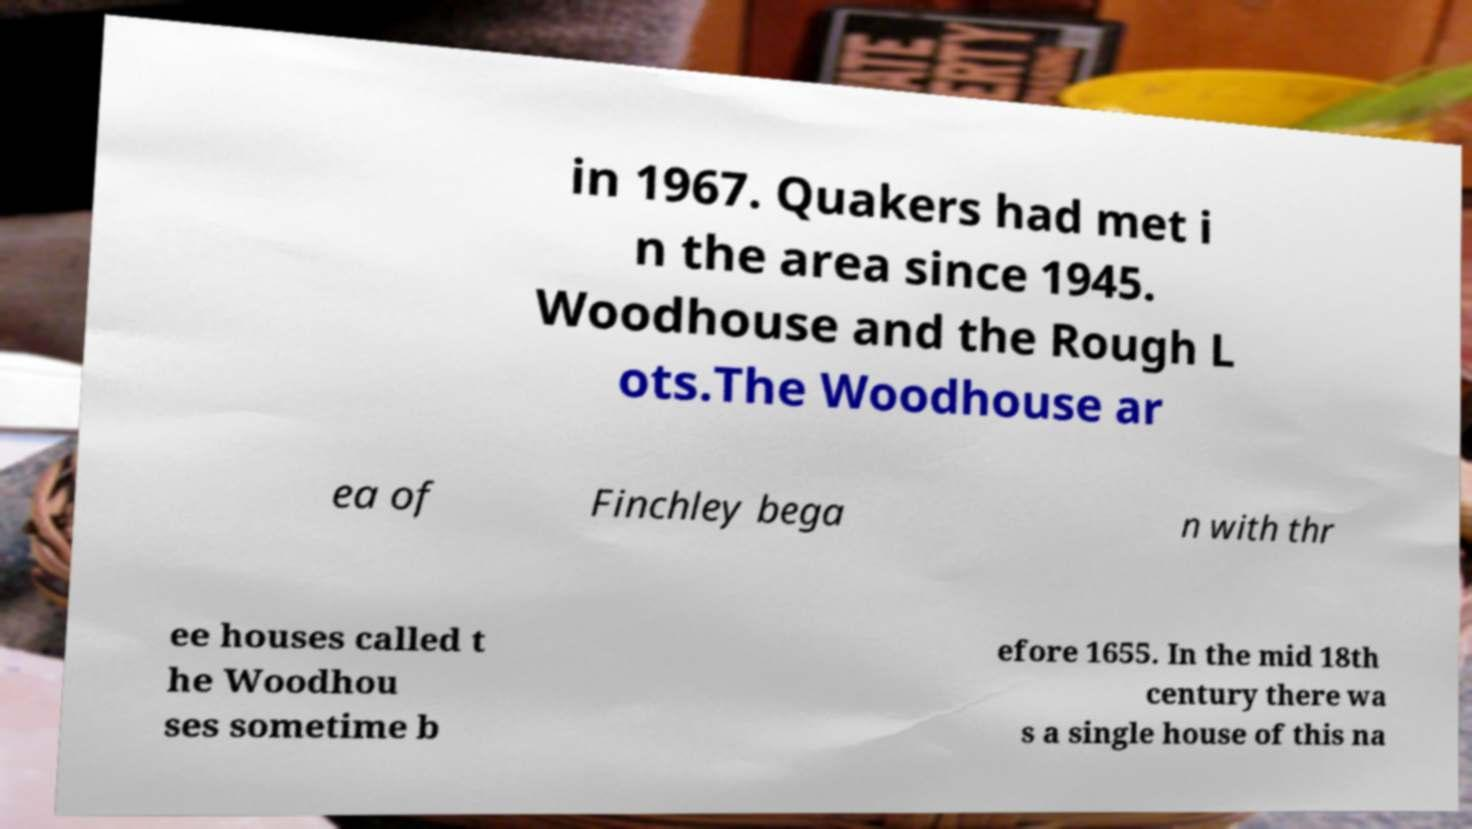Can you read and provide the text displayed in the image?This photo seems to have some interesting text. Can you extract and type it out for me? in 1967. Quakers had met i n the area since 1945. Woodhouse and the Rough L ots.The Woodhouse ar ea of Finchley bega n with thr ee houses called t he Woodhou ses sometime b efore 1655. In the mid 18th century there wa s a single house of this na 